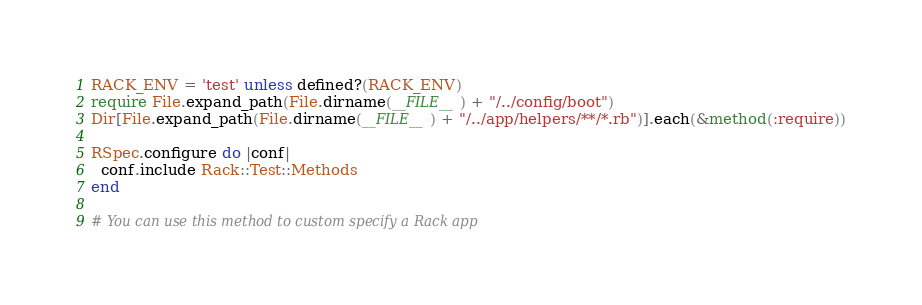Convert code to text. <code><loc_0><loc_0><loc_500><loc_500><_Ruby_>RACK_ENV = 'test' unless defined?(RACK_ENV)
require File.expand_path(File.dirname(__FILE__) + "/../config/boot")
Dir[File.expand_path(File.dirname(__FILE__) + "/../app/helpers/**/*.rb")].each(&method(:require))

RSpec.configure do |conf|
  conf.include Rack::Test::Methods
end

# You can use this method to custom specify a Rack app</code> 